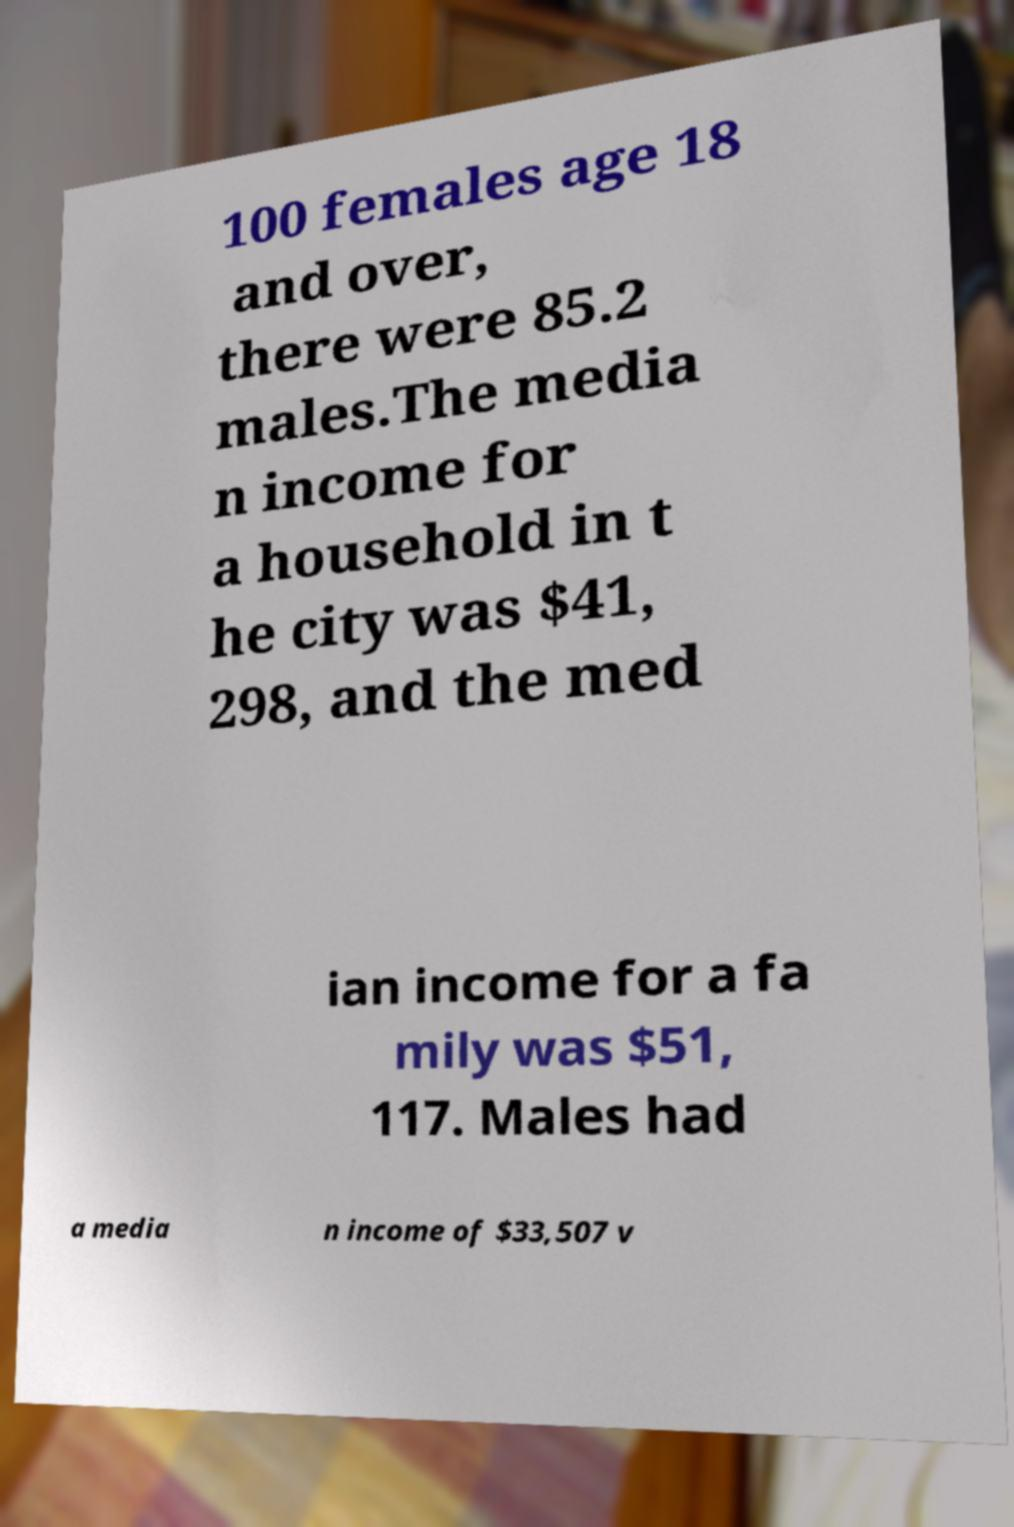I need the written content from this picture converted into text. Can you do that? 100 females age 18 and over, there were 85.2 males.The media n income for a household in t he city was $41, 298, and the med ian income for a fa mily was $51, 117. Males had a media n income of $33,507 v 